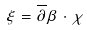Convert formula to latex. <formula><loc_0><loc_0><loc_500><loc_500>\xi = \overline { \partial } \beta \cdot \chi</formula> 